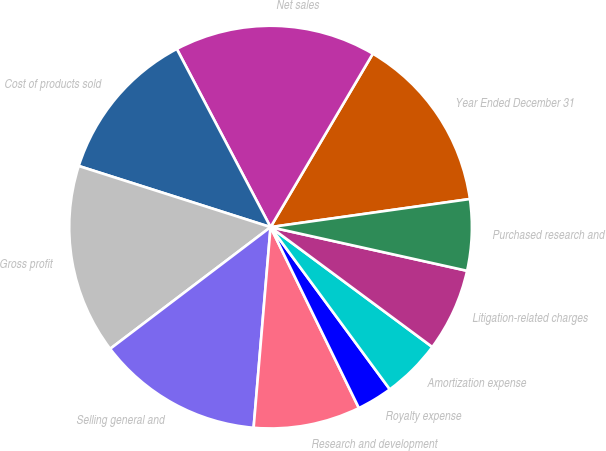<chart> <loc_0><loc_0><loc_500><loc_500><pie_chart><fcel>Year Ended December 31<fcel>Net sales<fcel>Cost of products sold<fcel>Gross profit<fcel>Selling general and<fcel>Research and development<fcel>Royalty expense<fcel>Amortization expense<fcel>Litigation-related charges<fcel>Purchased research and<nl><fcel>14.29%<fcel>16.19%<fcel>12.38%<fcel>15.24%<fcel>13.33%<fcel>8.57%<fcel>2.86%<fcel>4.76%<fcel>6.67%<fcel>5.71%<nl></chart> 